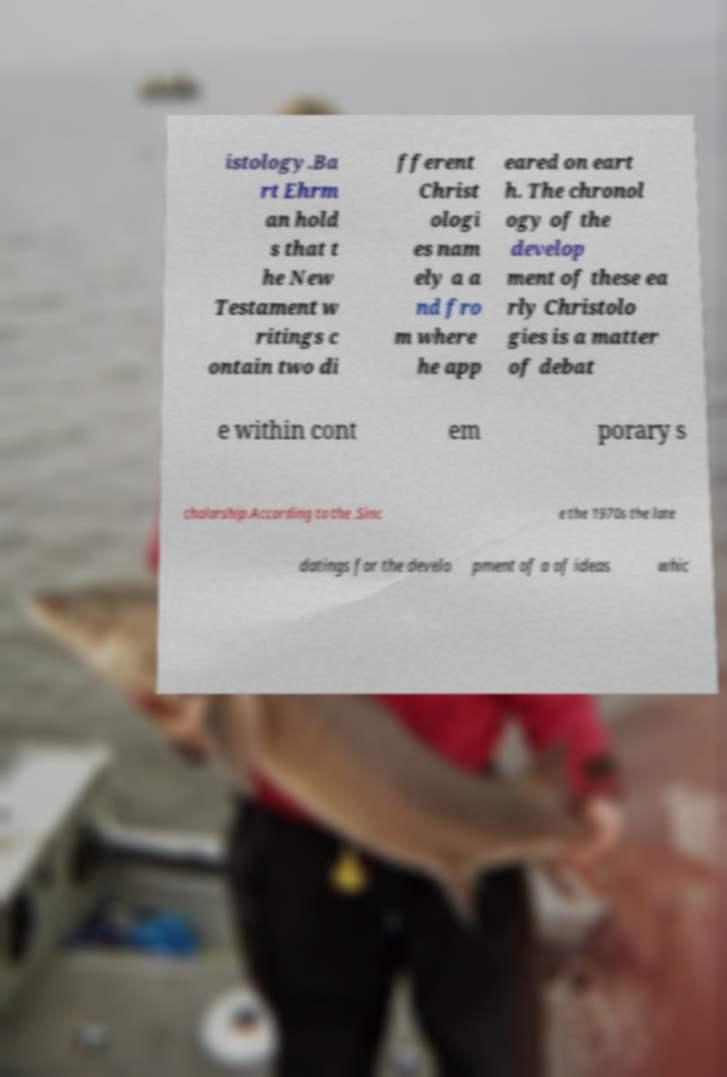Could you assist in decoding the text presented in this image and type it out clearly? istology.Ba rt Ehrm an hold s that t he New Testament w ritings c ontain two di fferent Christ ologi es nam ely a a nd fro m where he app eared on eart h. The chronol ogy of the develop ment of these ea rly Christolo gies is a matter of debat e within cont em porary s cholarship.According to the .Sinc e the 1970s the late datings for the develo pment of a of ideas whic 